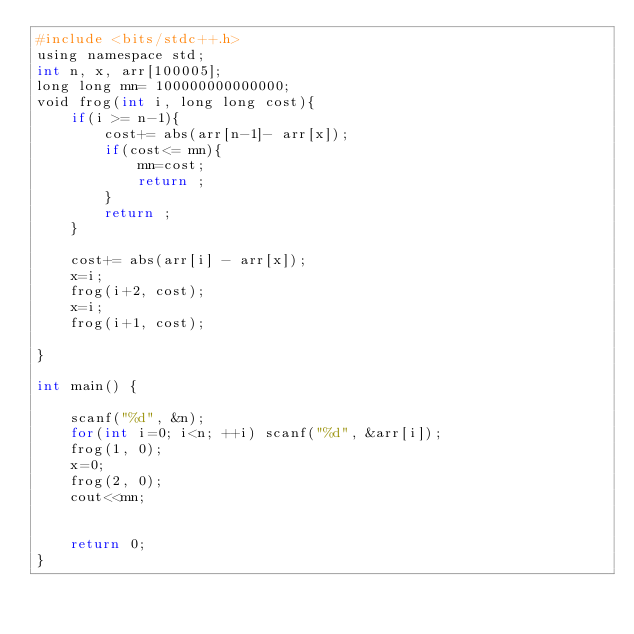<code> <loc_0><loc_0><loc_500><loc_500><_Awk_>#include <bits/stdc++.h>
using namespace std;
int n, x, arr[100005];
long long mn= 100000000000000;
void frog(int i, long long cost){
	if(i >= n-1){
		cost+= abs(arr[n-1]- arr[x]);
		if(cost<= mn){
			mn=cost;
			return ;
		}
		return ;
	}
	
	cost+= abs(arr[i] - arr[x]);
	x=i;
	frog(i+2, cost);
	x=i;
	frog(i+1, cost);
	
}

int main() {
	
	scanf("%d", &n);
	for(int i=0; i<n; ++i) scanf("%d", &arr[i]);
	frog(1, 0);
	x=0;
	frog(2, 0);
	cout<<mn;
	
	
	return 0;
}</code> 